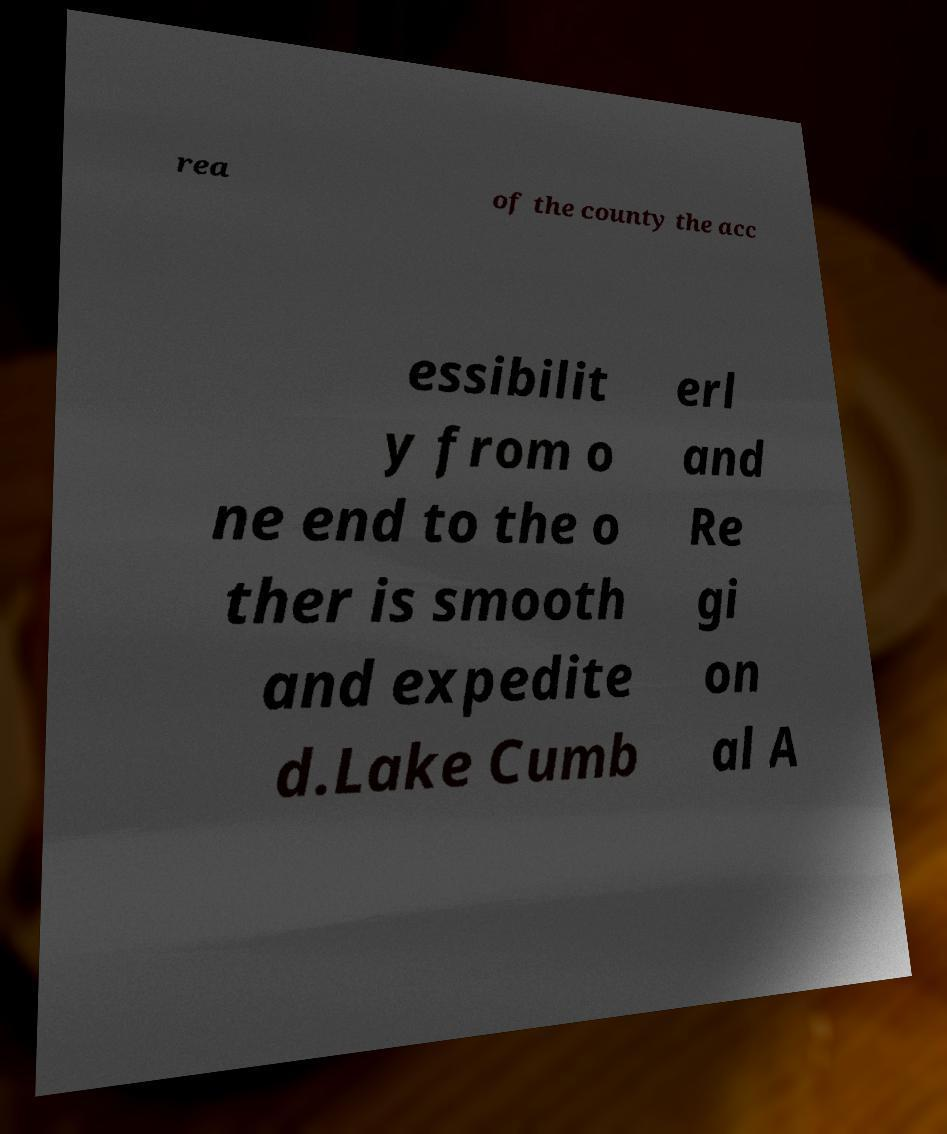Could you extract and type out the text from this image? rea of the county the acc essibilit y from o ne end to the o ther is smooth and expedite d.Lake Cumb erl and Re gi on al A 